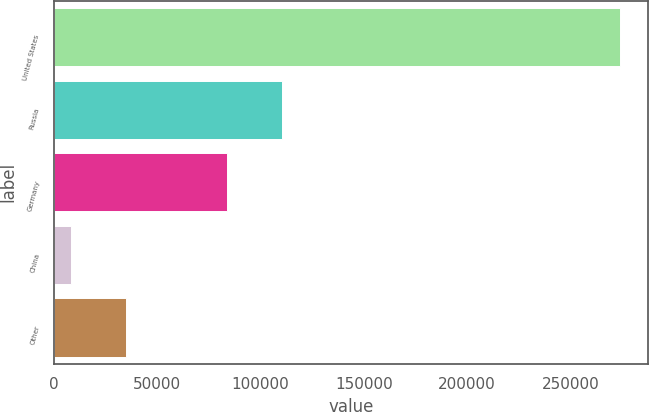<chart> <loc_0><loc_0><loc_500><loc_500><bar_chart><fcel>United States<fcel>Russia<fcel>Germany<fcel>China<fcel>Other<nl><fcel>273947<fcel>110402<fcel>83826<fcel>8191<fcel>34766.6<nl></chart> 